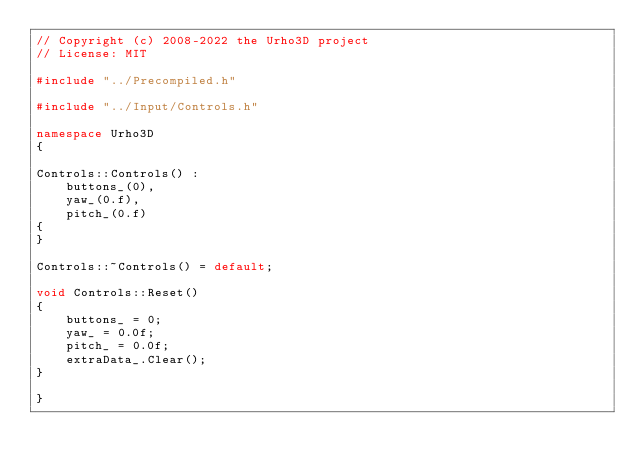Convert code to text. <code><loc_0><loc_0><loc_500><loc_500><_C++_>// Copyright (c) 2008-2022 the Urho3D project
// License: MIT

#include "../Precompiled.h"

#include "../Input/Controls.h"

namespace Urho3D
{

Controls::Controls() :
    buttons_(0),
    yaw_(0.f),
    pitch_(0.f)
{
}

Controls::~Controls() = default;

void Controls::Reset()
{
    buttons_ = 0;
    yaw_ = 0.0f;
    pitch_ = 0.0f;
    extraData_.Clear();
}

}
</code> 